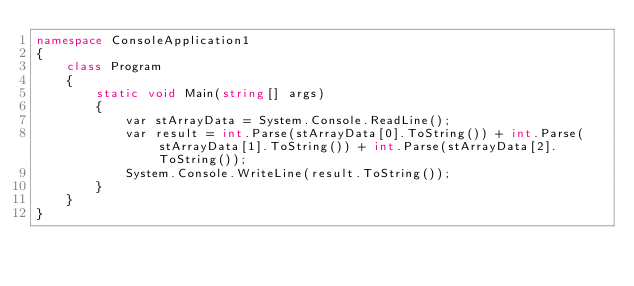Convert code to text. <code><loc_0><loc_0><loc_500><loc_500><_C#_>namespace ConsoleApplication1
{
    class Program
    {
        static void Main(string[] args)
        {
            var stArrayData = System.Console.ReadLine();
            var result = int.Parse(stArrayData[0].ToString()) + int.Parse(stArrayData[1].ToString()) + int.Parse(stArrayData[2].ToString());
            System.Console.WriteLine(result.ToString());
        }
    }
}</code> 